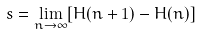<formula> <loc_0><loc_0><loc_500><loc_500>s = \lim _ { n \to \infty } [ H ( n + 1 ) - H ( n ) ]</formula> 